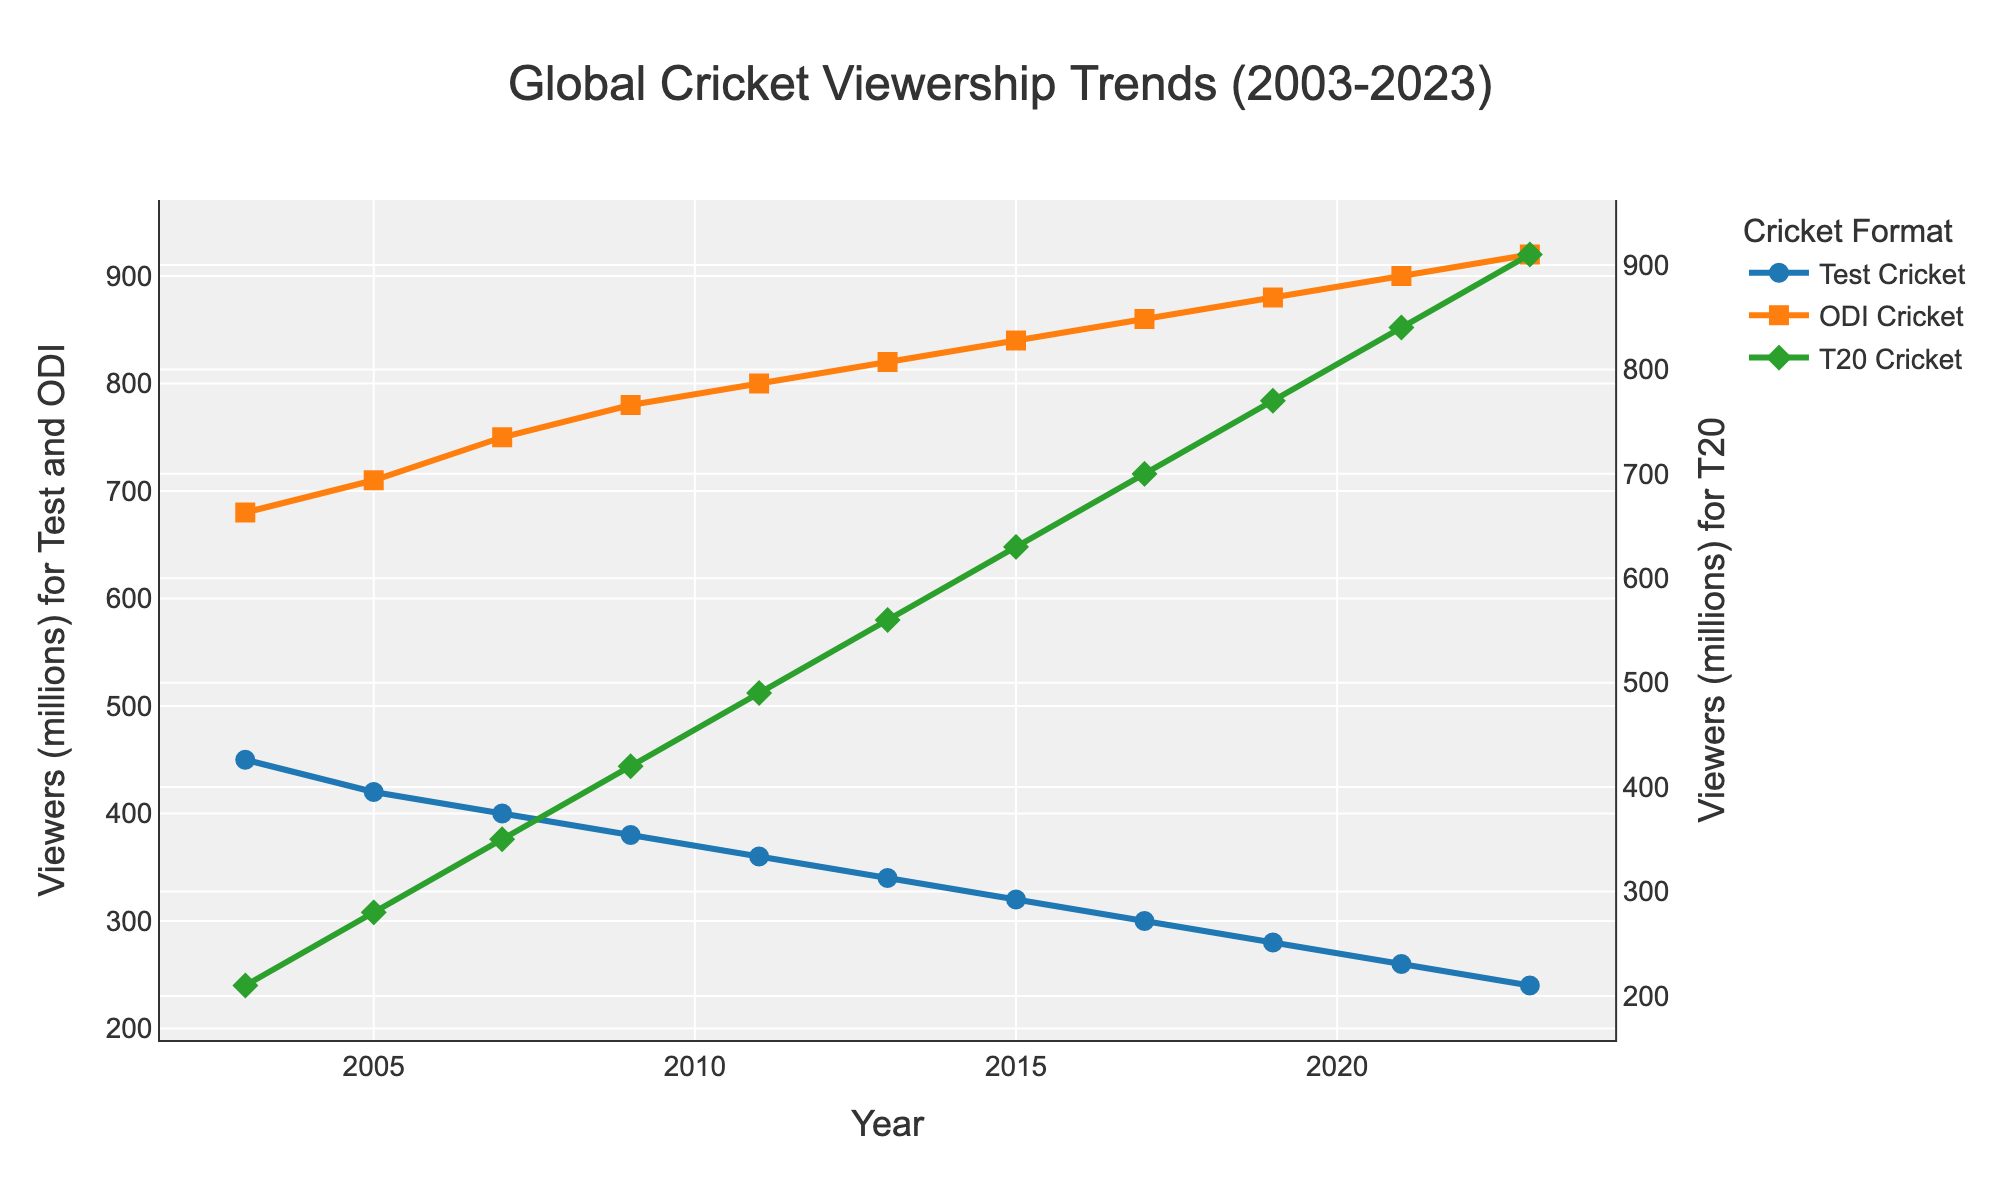Which cricket format had the highest viewership in 2023? The viewership numbers for 2023 show that T20 cricket had 910 million viewers, which is higher than ODI cricket (920 million) and Test cricket (240 million).
Answer: T20 cricket How many viewers did ODI cricket gain between 2003 and 2023? In 2003, ODI cricket had 680 million viewers. By 2023, this increased to 920 million viewers. The gain is calculated as 920 million - 680 million = 240 million.
Answer: 240 million Which year did Test and ODI cricket have the same trend, both showing a decrease in viewership? Both Test and ODI cricket show a consistent decline in viewership across all recorded years, starting from 2003 to 2023. Any year taken within this range exhibits this trend.
Answer: All years from 2003 to 2023 By how much did T20 cricket viewership increase from 2003 to 2011? In 2003, T20 cricket had 210 million viewers. By 2011, this increased to 490 million viewers. The increase is 490 million - 210 million = 280 million.
Answer: 280 million During which period did ODI cricket see the largest relative increase in viewership? From 2003 to 2009, ODI cricket increased from 680 million to 780 million, a gain of 100 million. From 2009 to 2015, it increased from 780 million to 840 million, a gain of 60 million. From 2015 to 2023, it increased from 840 million to 920 million, a gain of 80 million. The largest increase happened between 2003 to 2009.
Answer: 2003 to 2009 When did T20 cricket first surpass Test cricket in viewership? T20 cricket first surpassed Test cricket in 2007, when T20 cricket reached 350 million viewers compared to Test cricket with 400 million viewers, marking the beginning of a larger trend.
Answer: 2007 What was the average viewership for T20 cricket from 2003 to 2023? T20 cricket viewership numbers are 210, 280, 350, 420, 490, 560, 630, 700, 770, 840, and 910 from 2003 to 2023. The total sum is 6160 million, divided by 11 years gives an average of approximately 560 million.
Answer: 560 million Compare the viewership trend of Test and T20 cricket between 2003 and 2023. Test cricket saw a consistent decline from 450 million to 240 million viewers. In contrast, T20 cricket viewership rapidly increased from 210 million to 910 million over the same period.
Answer: Test decreased, T20 increased How many years did it take for T20 cricket viewership to double from its initial viewership in 2003? Initially, T20 cricket had 210 million viewers in 2003. It doubled to 420 million viewers by 2009, taking 6 years.
Answer: 6 years 